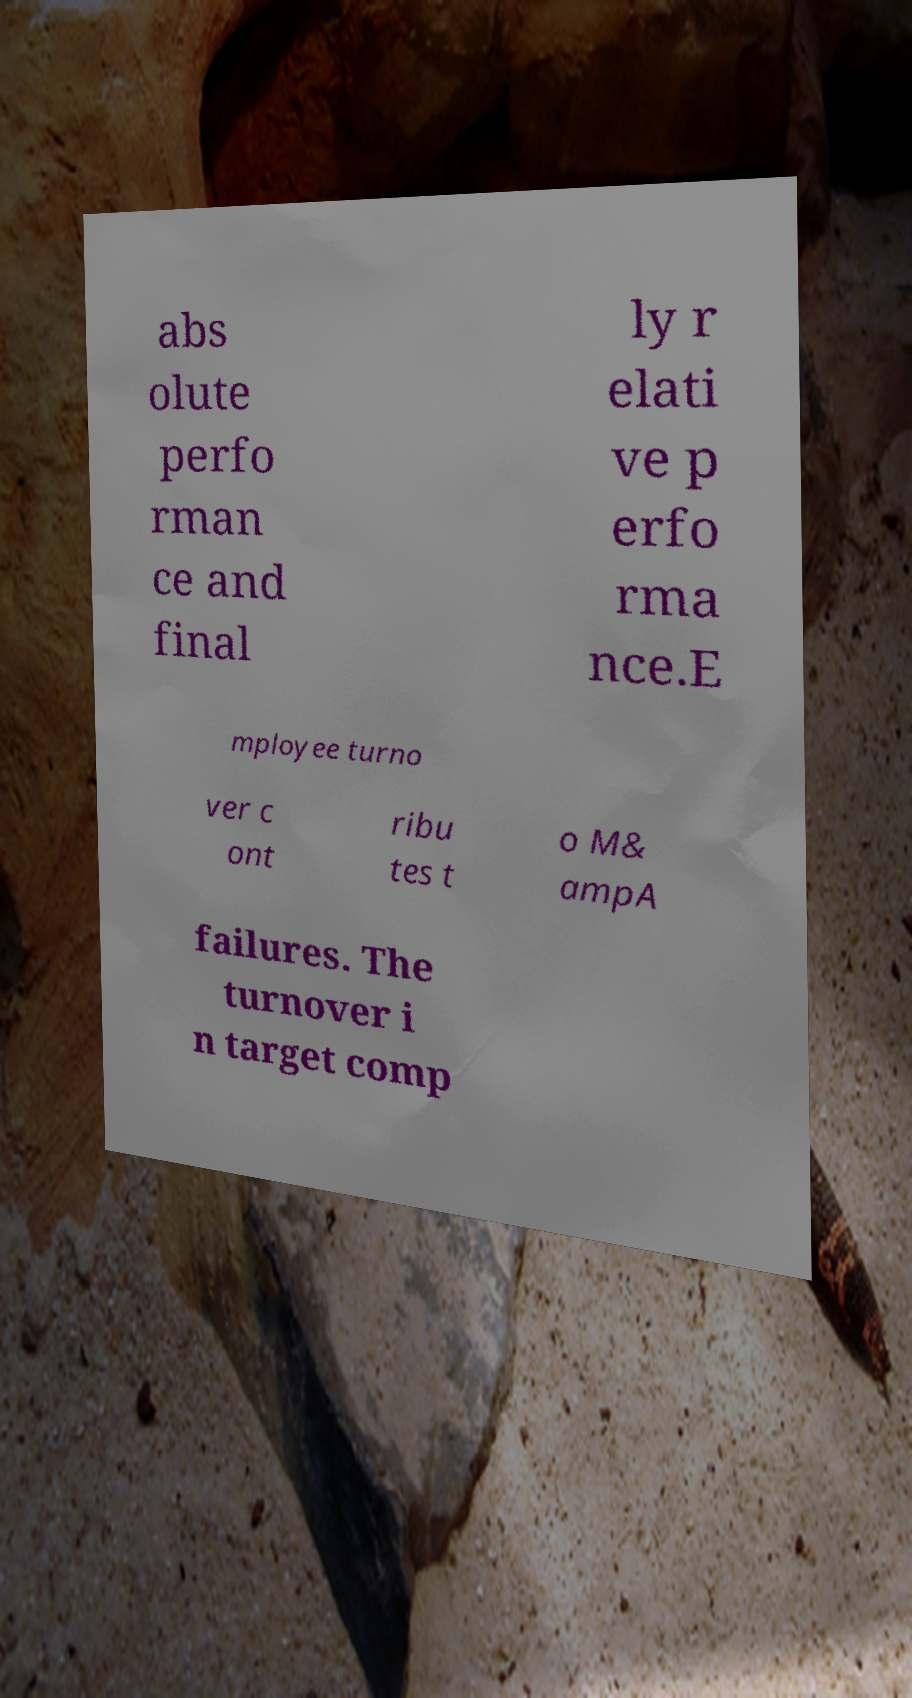Please read and relay the text visible in this image. What does it say? abs olute perfo rman ce and final ly r elati ve p erfo rma nce.E mployee turno ver c ont ribu tes t o M& ampA failures. The turnover i n target comp 